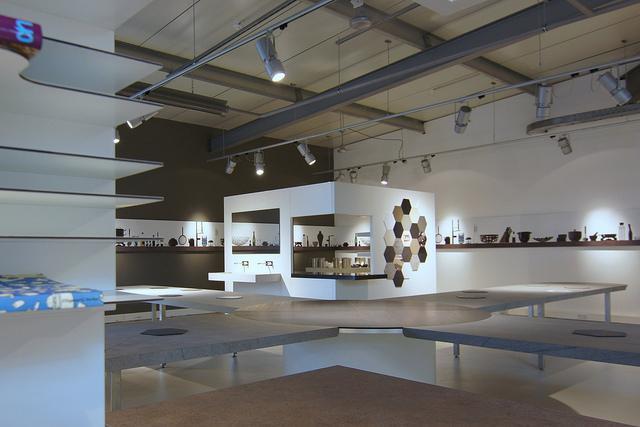How many shots in this scene?
Give a very brief answer. 1. How many dining tables are visible?
Give a very brief answer. 3. 